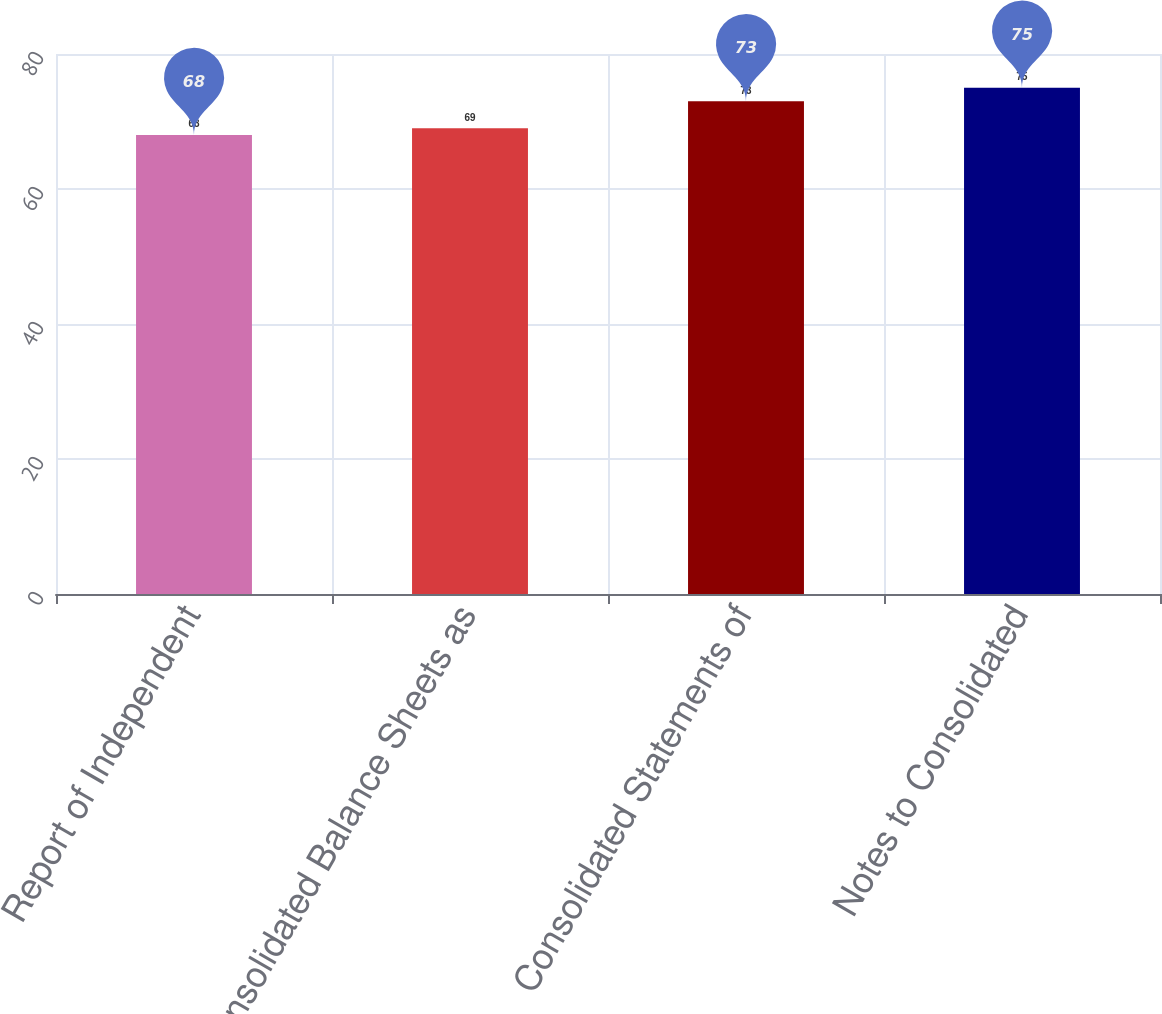Convert chart. <chart><loc_0><loc_0><loc_500><loc_500><bar_chart><fcel>Report of Independent<fcel>Consolidated Balance Sheets as<fcel>Consolidated Statements of<fcel>Notes to Consolidated<nl><fcel>68<fcel>69<fcel>73<fcel>75<nl></chart> 